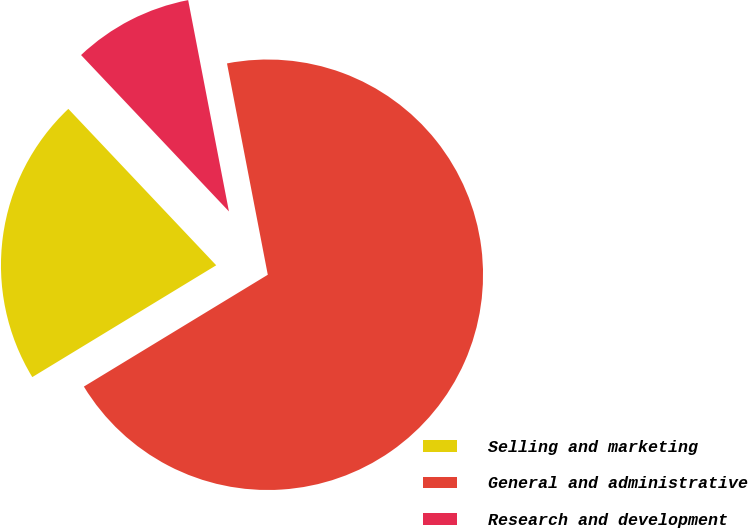Convert chart to OTSL. <chart><loc_0><loc_0><loc_500><loc_500><pie_chart><fcel>Selling and marketing<fcel>General and administrative<fcel>Research and development<nl><fcel>21.64%<fcel>69.34%<fcel>9.02%<nl></chart> 